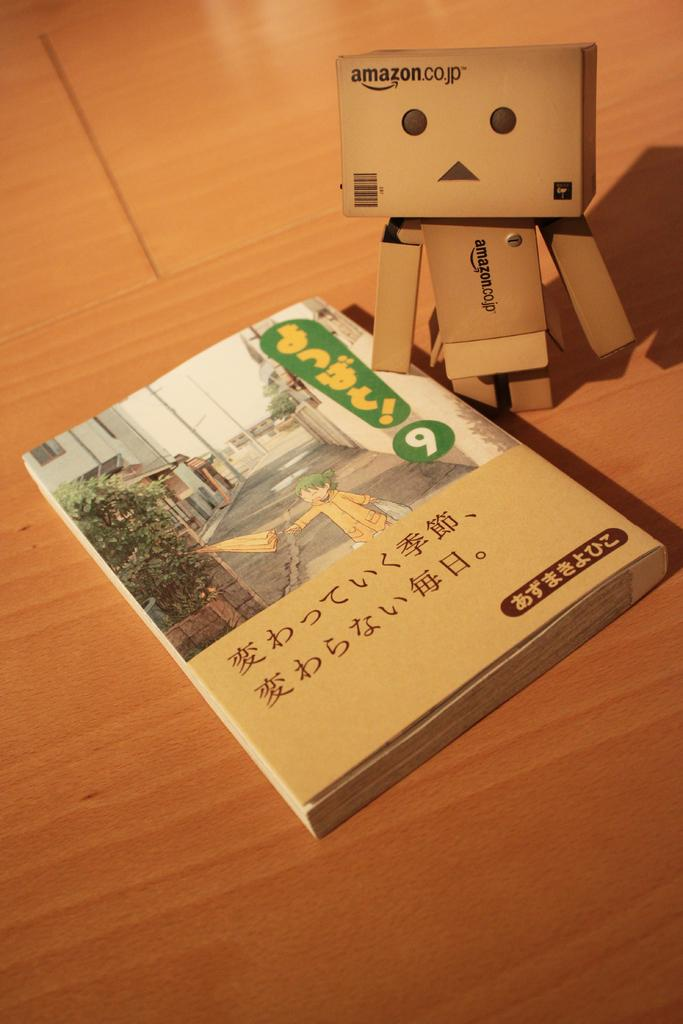<image>
Summarize the visual content of the image. a book in Japanese next to a box person with words Amazon.co.jp 